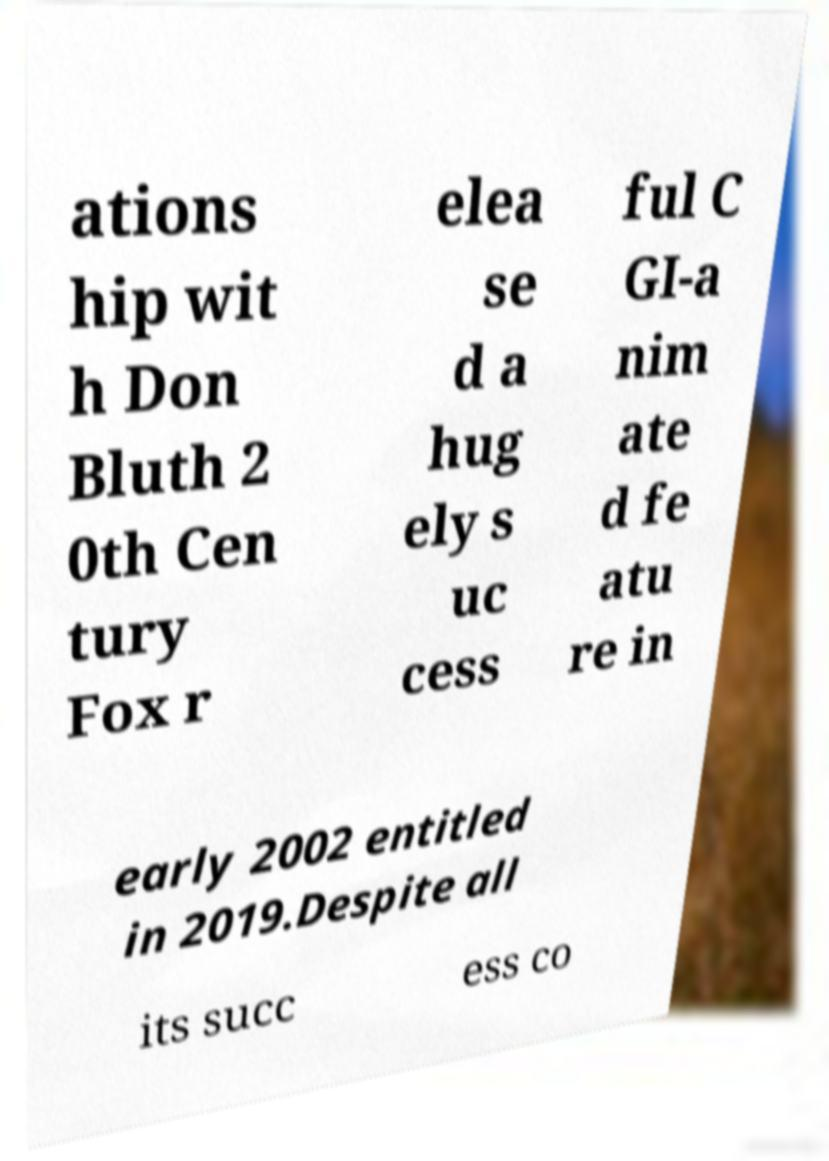There's text embedded in this image that I need extracted. Can you transcribe it verbatim? ations hip wit h Don Bluth 2 0th Cen tury Fox r elea se d a hug ely s uc cess ful C GI-a nim ate d fe atu re in early 2002 entitled in 2019.Despite all its succ ess co 